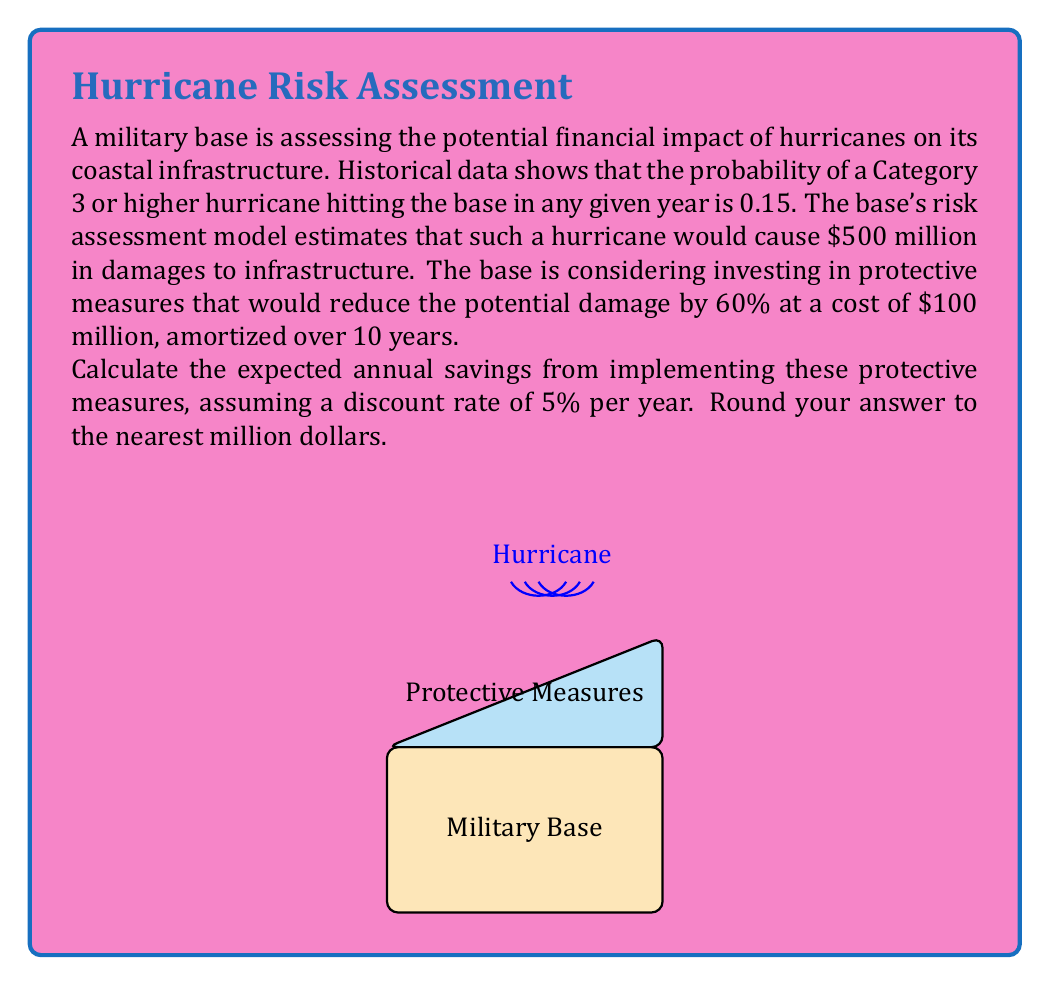Solve this math problem. Let's approach this problem step-by-step:

1) First, let's calculate the expected annual loss without protective measures:
   $$E(\text{Loss}) = 0.15 \times \$500\text{ million} = \$75\text{ million}$$

2) With protective measures, the potential damage is reduced by 60%:
   $$\text{New potential damage} = \$500\text{ million} \times (1 - 0.60) = \$200\text{ million}$$

3) The new expected annual loss with protective measures:
   $$E(\text{New Loss}) = 0.15 \times \$200\text{ million} = \$30\text{ million}$$

4) The annual savings in expected losses:
   $$\text{Annual Savings} = \$75\text{ million} - \$30\text{ million} = \$45\text{ million}$$

5) The cost of protective measures amortized over 10 years:
   $$\text{Annual Cost} = \frac{\$100\text{ million}}{10} = \$10\text{ million}$$

6) The net annual savings before considering the discount rate:
   $$\text{Net Annual Savings} = \$45\text{ million} - \$10\text{ million} = \$35\text{ million}$$

7) To account for the discount rate, we need to calculate the present value of these savings over 10 years:
   $$PV = \sum_{t=1}^{10} \frac{35}{(1 + 0.05)^t}$$

8) Using the formula for the present value of an annuity:
   $$PV = 35 \times \frac{1 - (1 + 0.05)^{-10}}{0.05} \approx \$270.44\text{ million}$$

9) The average annual savings over 10 years:
   $$\text{Average Annual Savings} = \frac{\$270.44\text{ million}}{10} \approx \$27.04\text{ million}$$

Rounding to the nearest million gives us $27 million.
Answer: $27 million 